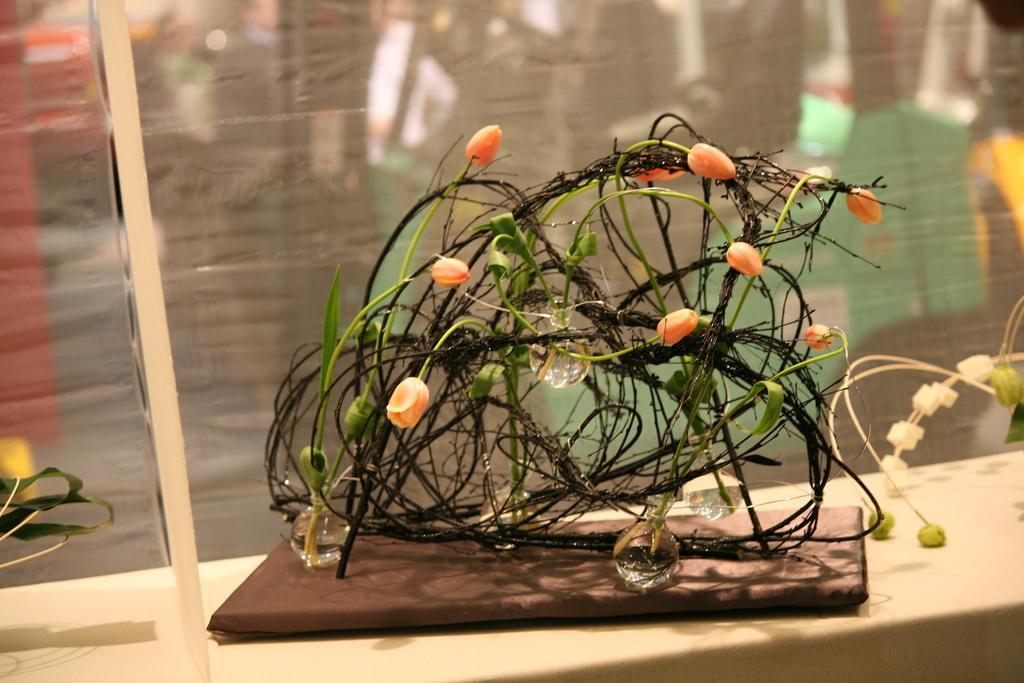Could you give a brief overview of what you see in this image? Here we can see a decorative object with bulbs and flower buds. There is a blur background. 